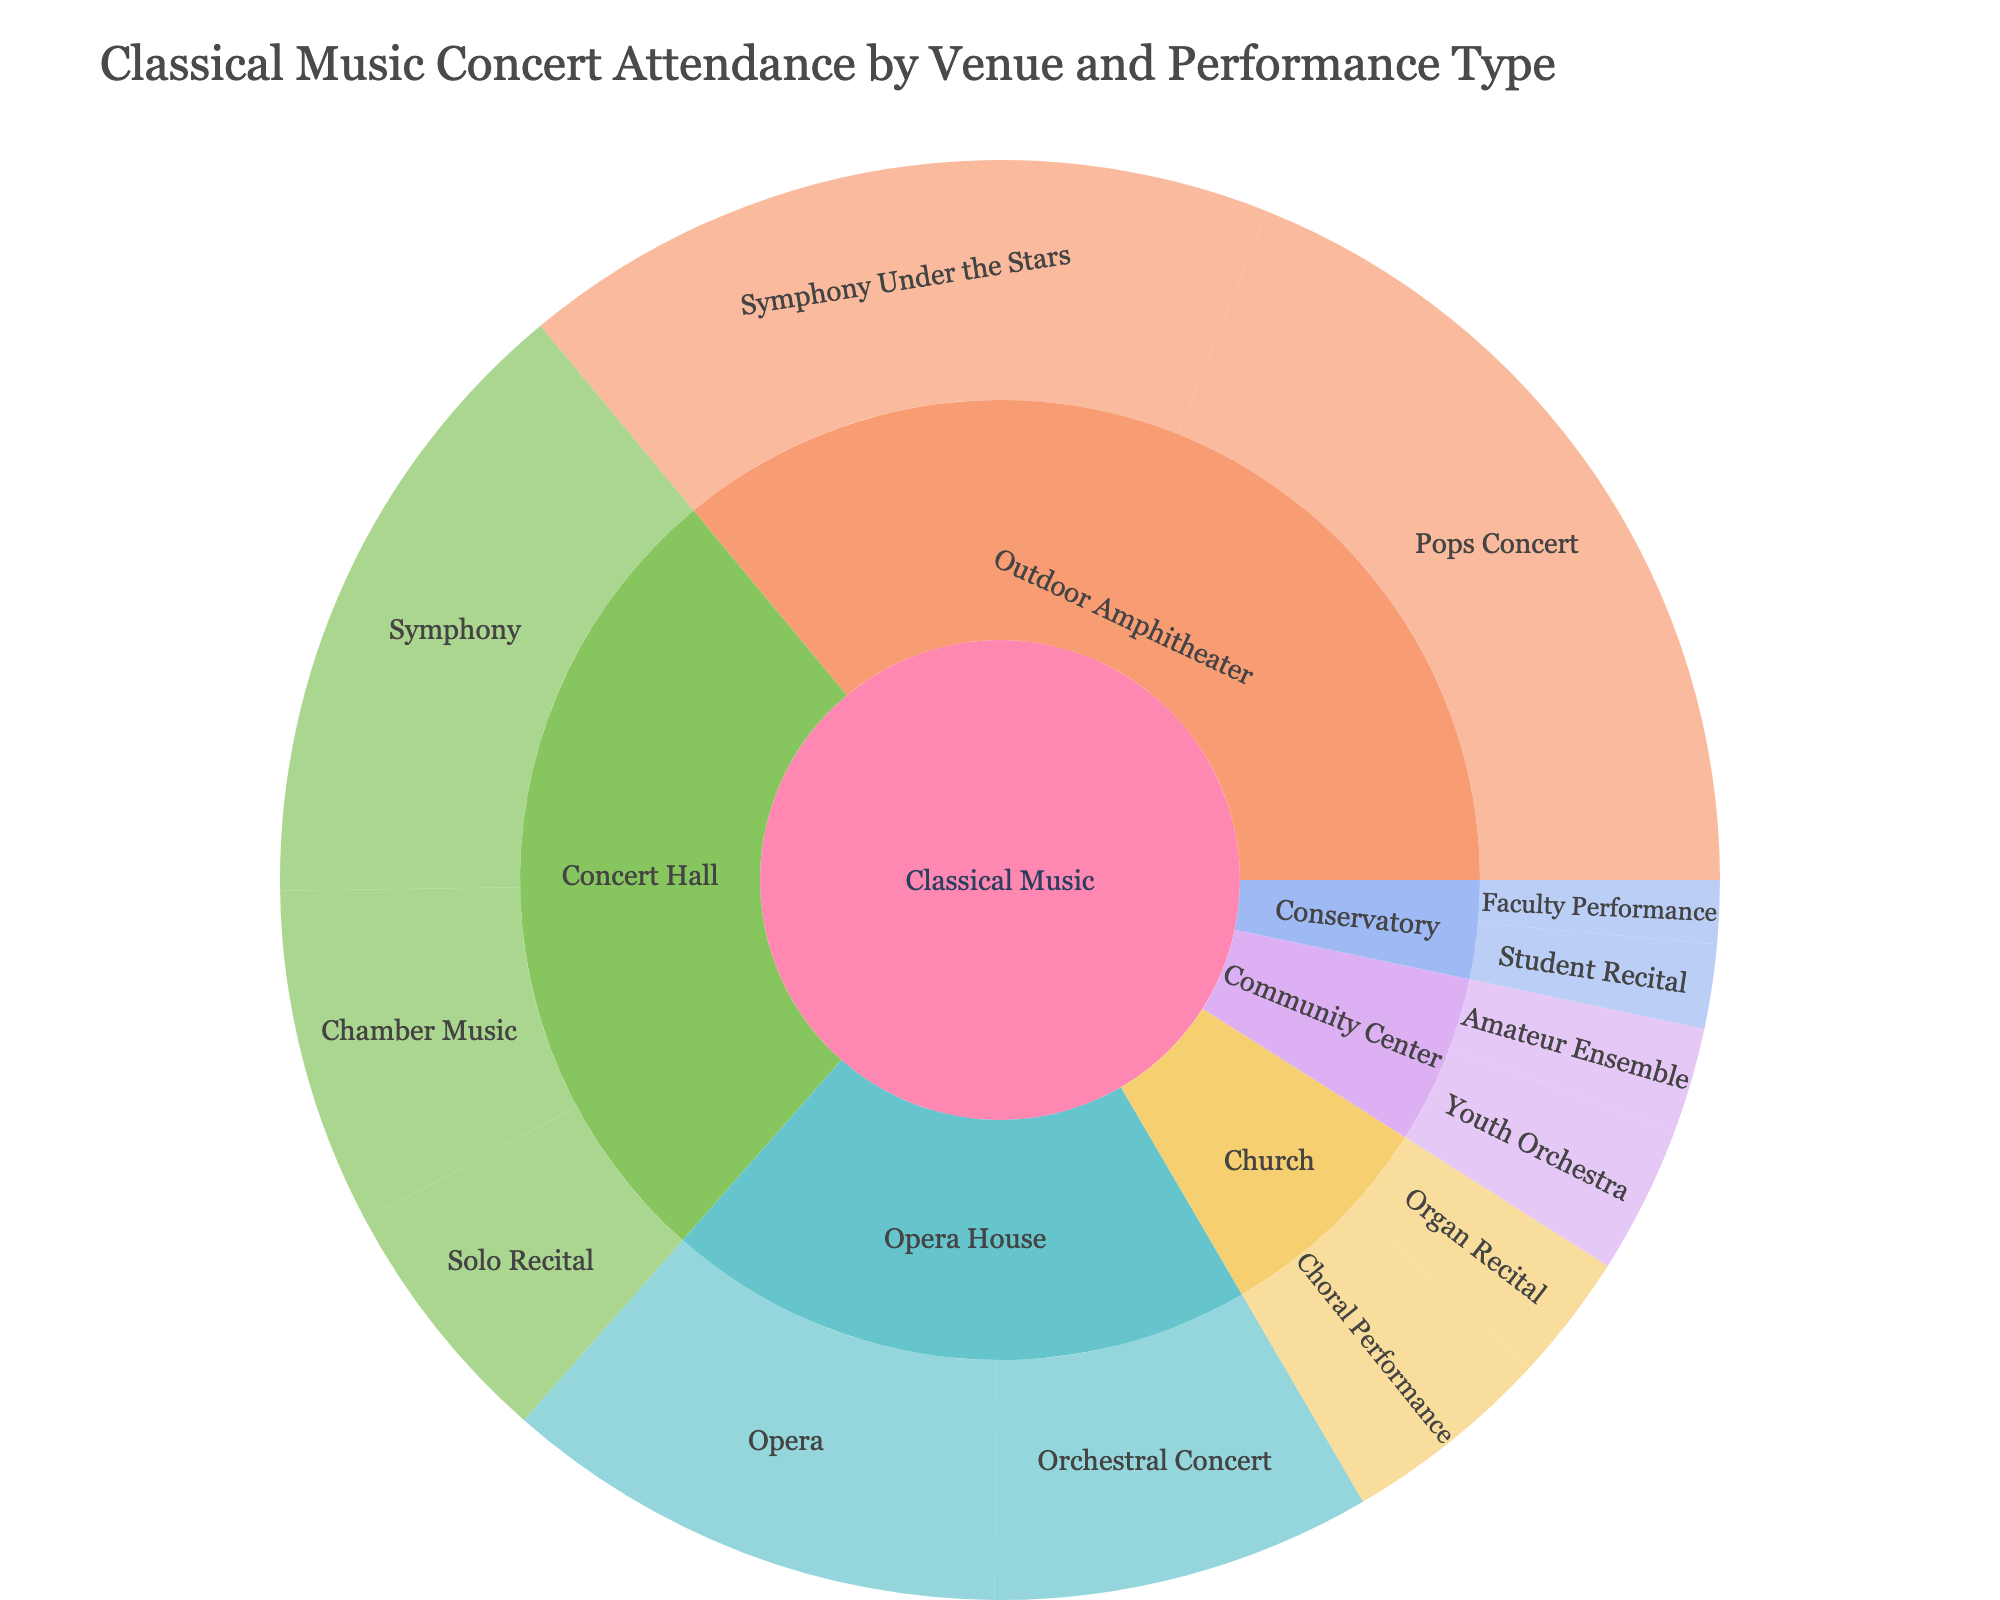What is the title of the figure? The title of the figure is located at the top.
Answer: Classical Music Concert Attendance by Venue and Performance Type Which venue type has the highest total attendance? Sum up the attendance numbers for each venue type. The outdoor amphitheater has the highest sum.
Answer: Outdoor Amphitheater How much higher is the attendance at Symphony Under the Stars compared to Student Recital? Compare the attendance values of Symphony Under the Stars (18,000) and Student Recital (2,000). Subtract the latter from the former.
Answer: 16,000 Which performance type in the Concert Hall has the lowest attendance? Look at the performance types within the Concert Hall and compare their attendance values.
Answer: Solo Recital What is the total attendance at the Opera House? Add up the attendance numbers for the performance types in the Opera House (Opera: 12,000, Orchestral Concert: 9,000).
Answer: 21,000 By how much is the attendance at Choral Performance and Organ Recital combined greater than Faculty Performance? Sum up the attendance of Choral Performance (5,000) and Organ Recital (3,000), then subtract the attendance of Faculty Performance (1,500).
Answer: 6,500 Compare attendance at Pops Concert and Symphony. Which one has higher attendance and by how much? Compare the attendance values of Pops Concert (20,000) and Symphony (15,000), then find the difference.
Answer: Pops Concert by 5,000 Which performance type under the Church venue has higher attendance? Compare the attendance figures for Choral Performance (5,000) and Organ Recital (3,000) under the Church venue.
Answer: Choral Performance If we combine the attendance of all performance types in the Community Center, what is the total? Add the attendances of Youth Orchestra (3,500) and Amateur Ensemble (2,500) under the Community Center.
Answer: 6,000 What is the average attendance of performances held in the Conservatory? Add the attendance values for Student Recital (2,000) and Faculty Performance (1,500), then divide by the number of performance types.
Answer: 1,750 